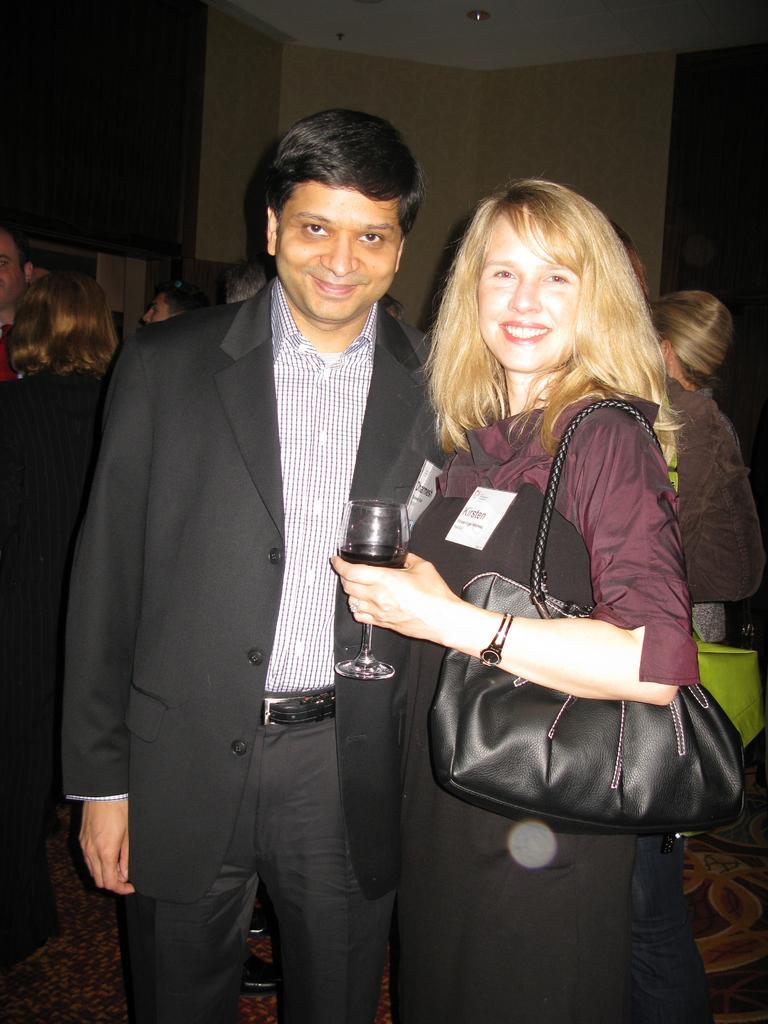How would you summarize this image in a sentence or two? There are two people standing. To the left side there is a man with black jacket is standing and he is smiling. And to the right side there is a lady holding a glass in her hand. She is standing and she is smiling. She is having a black color bag. Behind them there is are some people standing. 